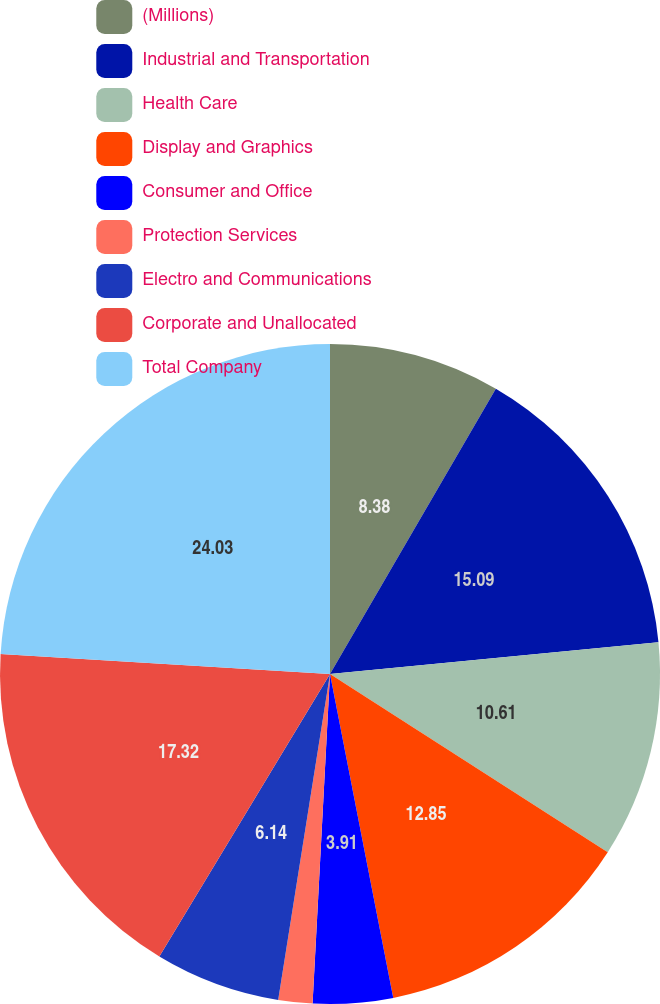Convert chart to OTSL. <chart><loc_0><loc_0><loc_500><loc_500><pie_chart><fcel>(Millions)<fcel>Industrial and Transportation<fcel>Health Care<fcel>Display and Graphics<fcel>Consumer and Office<fcel>Protection Services<fcel>Electro and Communications<fcel>Corporate and Unallocated<fcel>Total Company<nl><fcel>8.38%<fcel>15.09%<fcel>10.61%<fcel>12.85%<fcel>3.91%<fcel>1.67%<fcel>6.14%<fcel>17.32%<fcel>24.03%<nl></chart> 